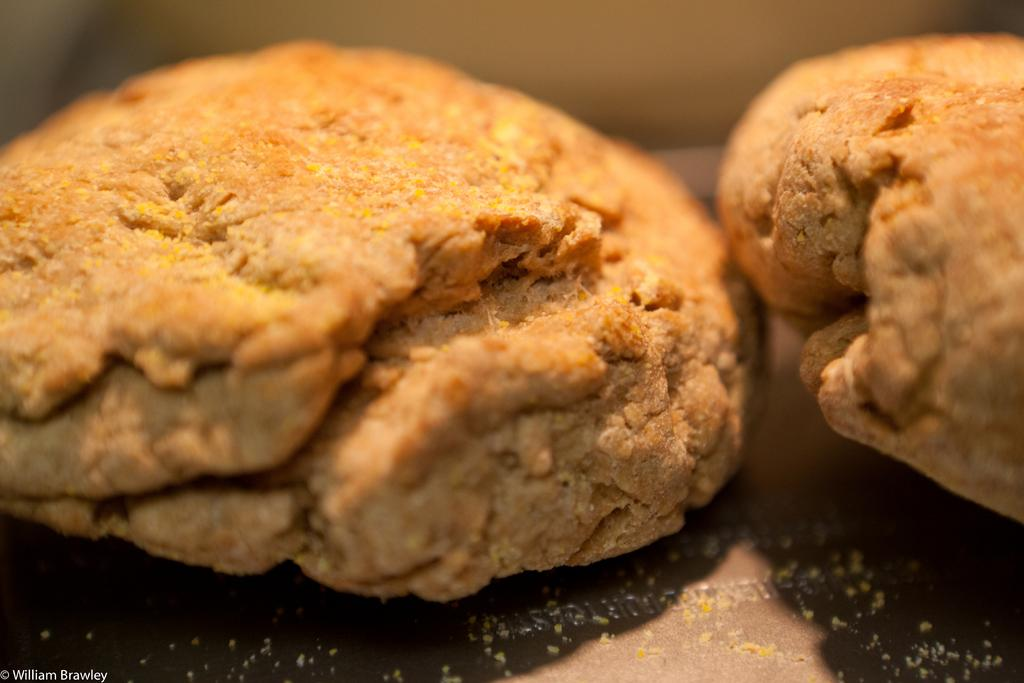What type of food can be seen on a plate in the image? There are cookies on a plate in the image. Can you describe the background of the image? The background of the image is blurred. What type of ornament is hanging from the front of the plate in the image? There is no ornament hanging from the front of the plate in the image; it only shows cookies on a plate. 